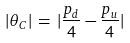<formula> <loc_0><loc_0><loc_500><loc_500>| \theta _ { C } | \, = \, | \frac { p _ { d } } 4 - \frac { p _ { u } } 4 |</formula> 